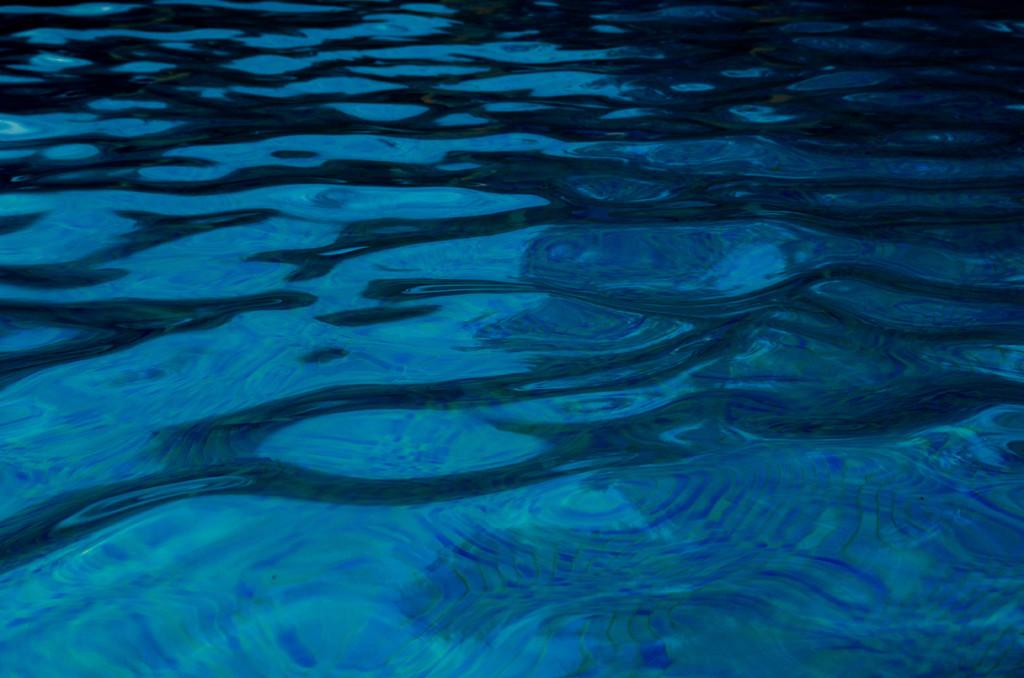What is the primary element visible in the image? There is water in the image. What color is the water in the image? Most of the water appears blue in color. Can you see any corn growing in the water in the image? There is no corn visible in the image; it only features water. Are there any planes flying over the water in the image? There is no mention of planes in the image, only water. 